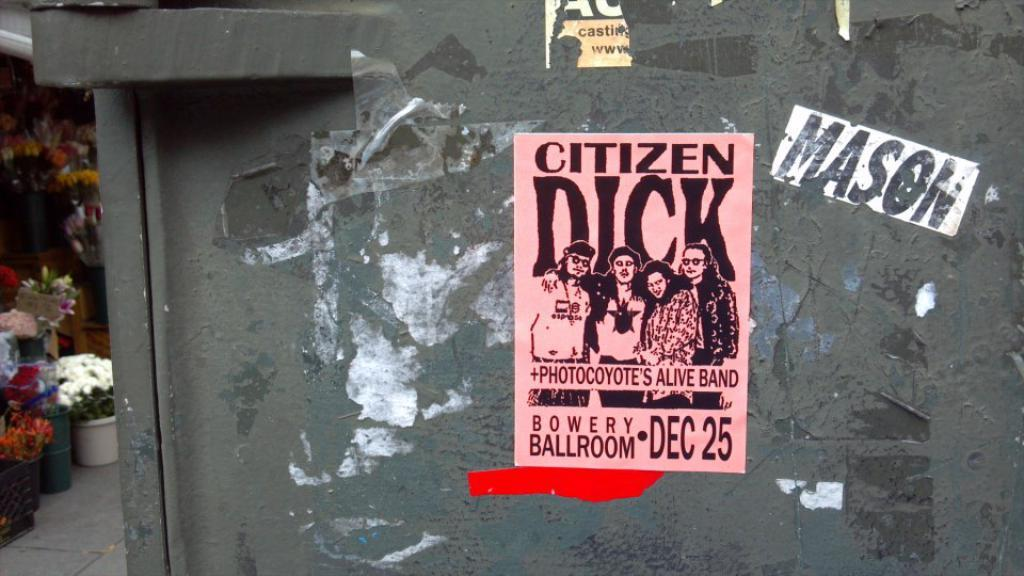Provide a one-sentence caption for the provided image. an ad poster for CITIZEN DICK + PHOTOCOYOTE'S ALIVE BAND at the BOWERY BALLROOM DEC 25 and a name MASON on the right of it.. 